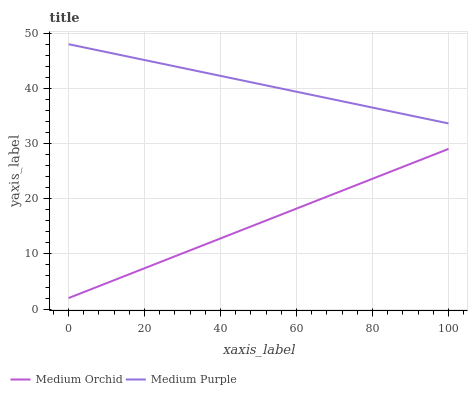Does Medium Orchid have the minimum area under the curve?
Answer yes or no. Yes. Does Medium Purple have the maximum area under the curve?
Answer yes or no. Yes. Does Medium Orchid have the maximum area under the curve?
Answer yes or no. No. Is Medium Orchid the smoothest?
Answer yes or no. Yes. Is Medium Purple the roughest?
Answer yes or no. Yes. Is Medium Orchid the roughest?
Answer yes or no. No. Does Medium Orchid have the lowest value?
Answer yes or no. Yes. Does Medium Purple have the highest value?
Answer yes or no. Yes. Does Medium Orchid have the highest value?
Answer yes or no. No. Is Medium Orchid less than Medium Purple?
Answer yes or no. Yes. Is Medium Purple greater than Medium Orchid?
Answer yes or no. Yes. Does Medium Orchid intersect Medium Purple?
Answer yes or no. No. 